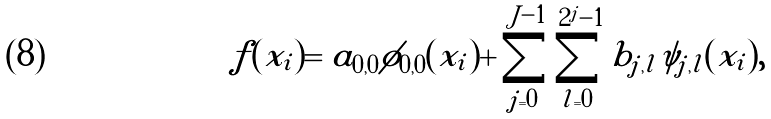Convert formula to latex. <formula><loc_0><loc_0><loc_500><loc_500>f ( x _ { i } ) = a _ { 0 , 0 } \phi _ { 0 , 0 } ( x _ { i } ) + \sum _ { j = 0 } ^ { J - 1 } \sum _ { l = 0 } ^ { 2 ^ { j } - 1 } b _ { j , l } \psi _ { j , l } ( x _ { i } ) ,</formula> 